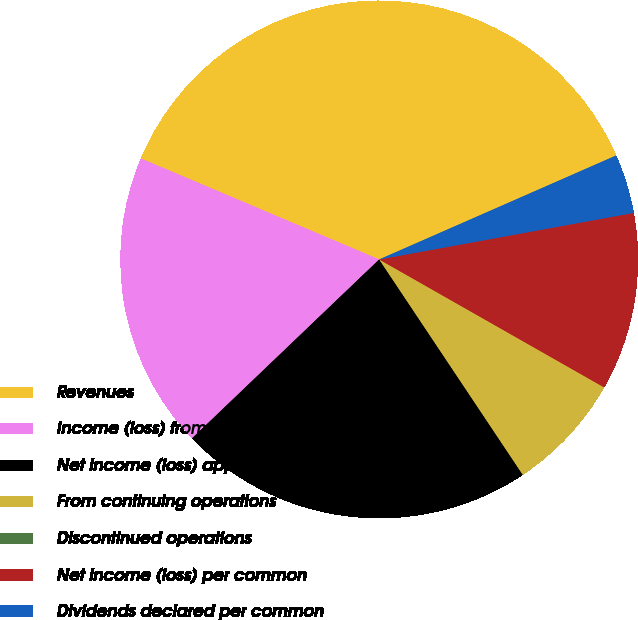Convert chart. <chart><loc_0><loc_0><loc_500><loc_500><pie_chart><fcel>Revenues<fcel>Income (loss) from continuing<fcel>Net income (loss) applicable<fcel>From continuing operations<fcel>Discontinued operations<fcel>Net income (loss) per common<fcel>Dividends declared per common<nl><fcel>37.04%<fcel>18.52%<fcel>22.22%<fcel>7.41%<fcel>0.0%<fcel>11.11%<fcel>3.7%<nl></chart> 